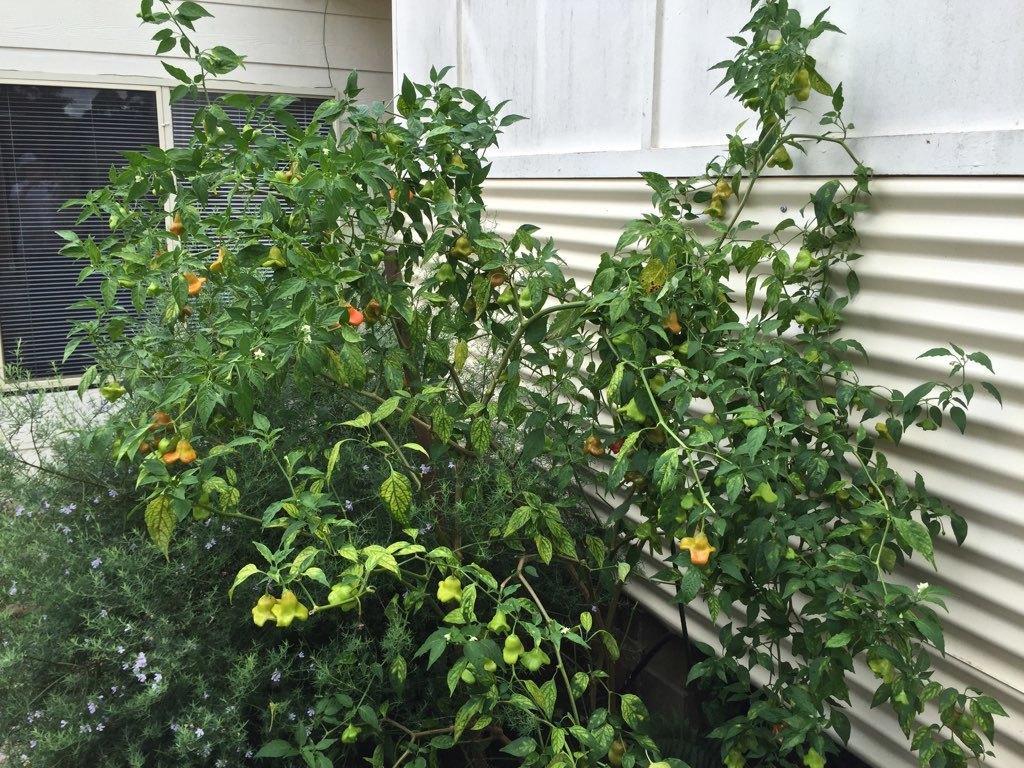Could you give a brief overview of what you see in this image? This image consists of a plant which is having flowers. In the background, there is a window along with a wall. To the right, there is a wall and a metal sheet. 